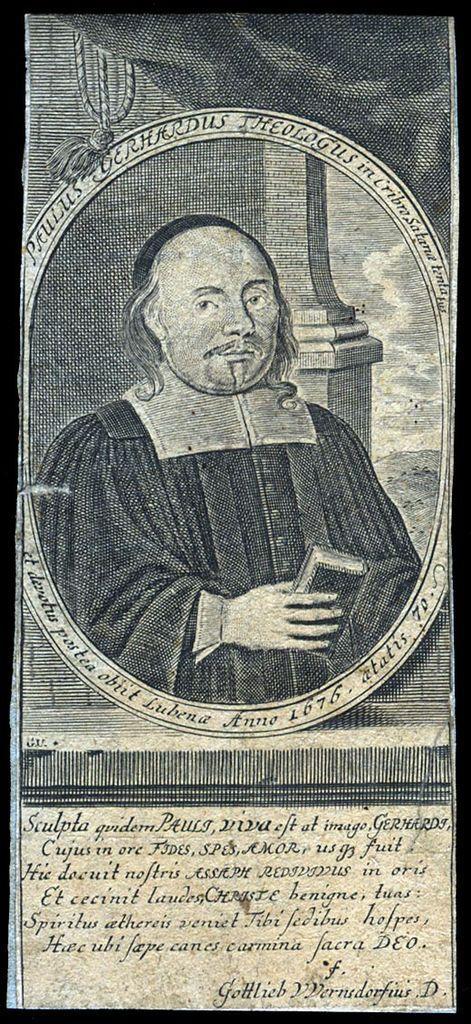How would you summarize this image in a sentence or two? The picture is a page cover. In this picture there is a person. At the bottom there is text. The picture has black border. 